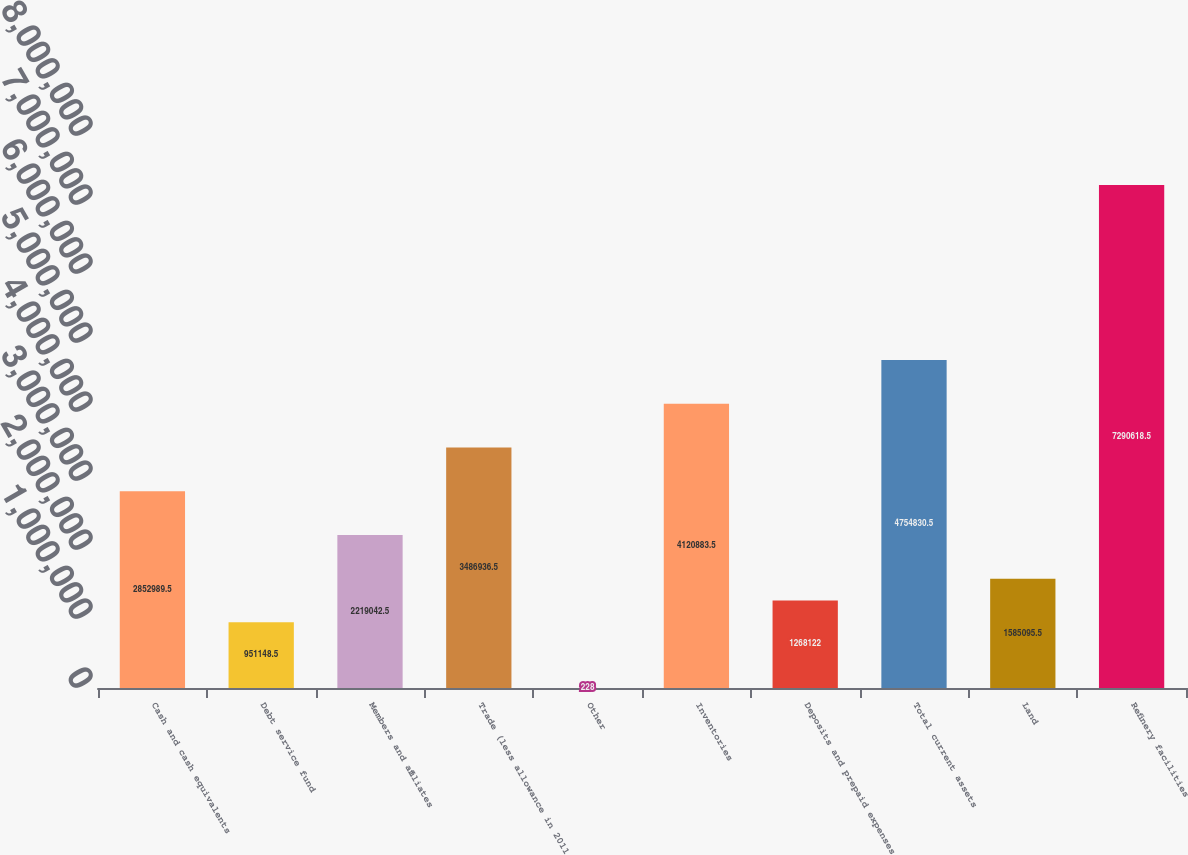<chart> <loc_0><loc_0><loc_500><loc_500><bar_chart><fcel>Cash and cash equivalents<fcel>Debt service fund<fcel>Members and affiliates<fcel>Trade (less allowance in 2011<fcel>Other<fcel>Inventories<fcel>Deposits and prepaid expenses<fcel>Total current assets<fcel>Land<fcel>Refinery facilities<nl><fcel>2.85299e+06<fcel>951148<fcel>2.21904e+06<fcel>3.48694e+06<fcel>228<fcel>4.12088e+06<fcel>1.26812e+06<fcel>4.75483e+06<fcel>1.5851e+06<fcel>7.29062e+06<nl></chart> 